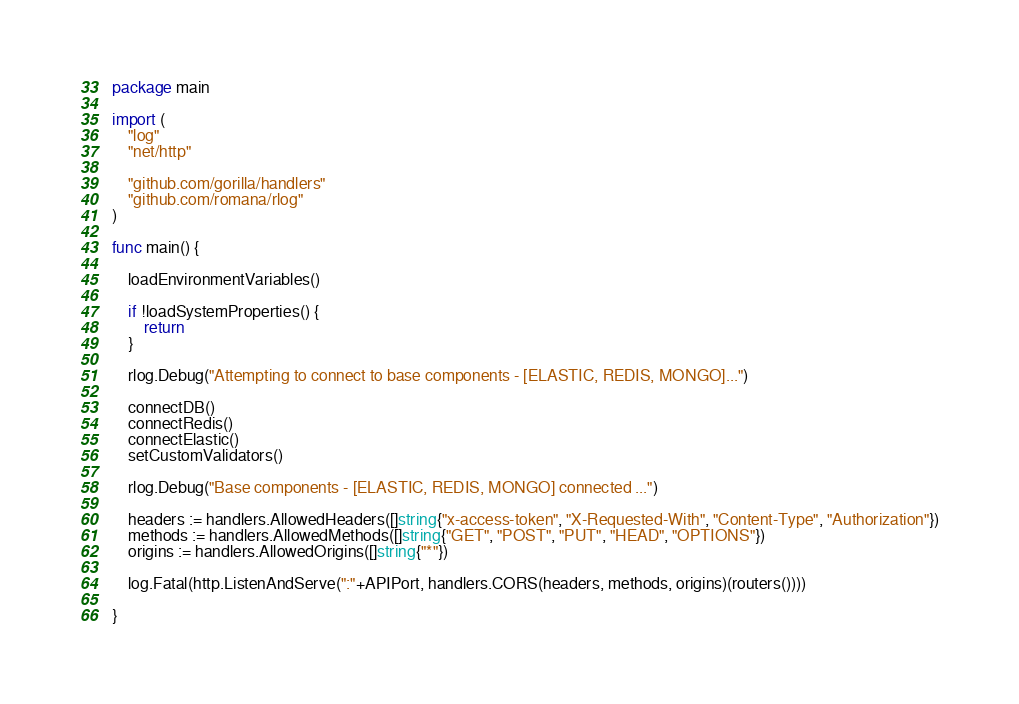<code> <loc_0><loc_0><loc_500><loc_500><_Go_>package main

import (
	"log"
	"net/http"

	"github.com/gorilla/handlers"
	"github.com/romana/rlog"
)

func main() {

	loadEnvironmentVariables()

	if !loadSystemProperties() {
		return
	}

	rlog.Debug("Attempting to connect to base components - [ELASTIC, REDIS, MONGO]...")

	connectDB()
	connectRedis()
	connectElastic()
	setCustomValidators()

	rlog.Debug("Base components - [ELASTIC, REDIS, MONGO] connected ...")

	headers := handlers.AllowedHeaders([]string{"x-access-token", "X-Requested-With", "Content-Type", "Authorization"})
	methods := handlers.AllowedMethods([]string{"GET", "POST", "PUT", "HEAD", "OPTIONS"})
	origins := handlers.AllowedOrigins([]string{"*"})

	log.Fatal(http.ListenAndServe(":"+APIPort, handlers.CORS(headers, methods, origins)(routers())))

}
</code> 